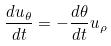<formula> <loc_0><loc_0><loc_500><loc_500>\frac { d u _ { \theta } } { d t } = - \frac { d \theta } { d t } u _ { \rho }</formula> 